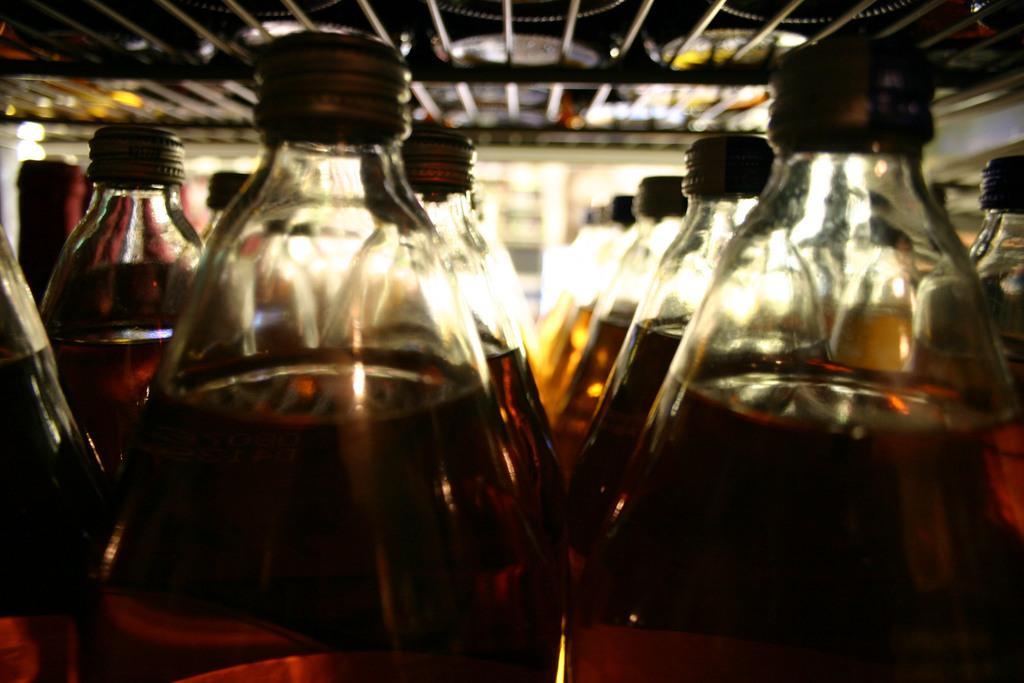In one or two sentences, can you explain what this image depicts? In this image there are many bottles filled with a drink in it and closed with a cap. At the top of the image there is a grill. 